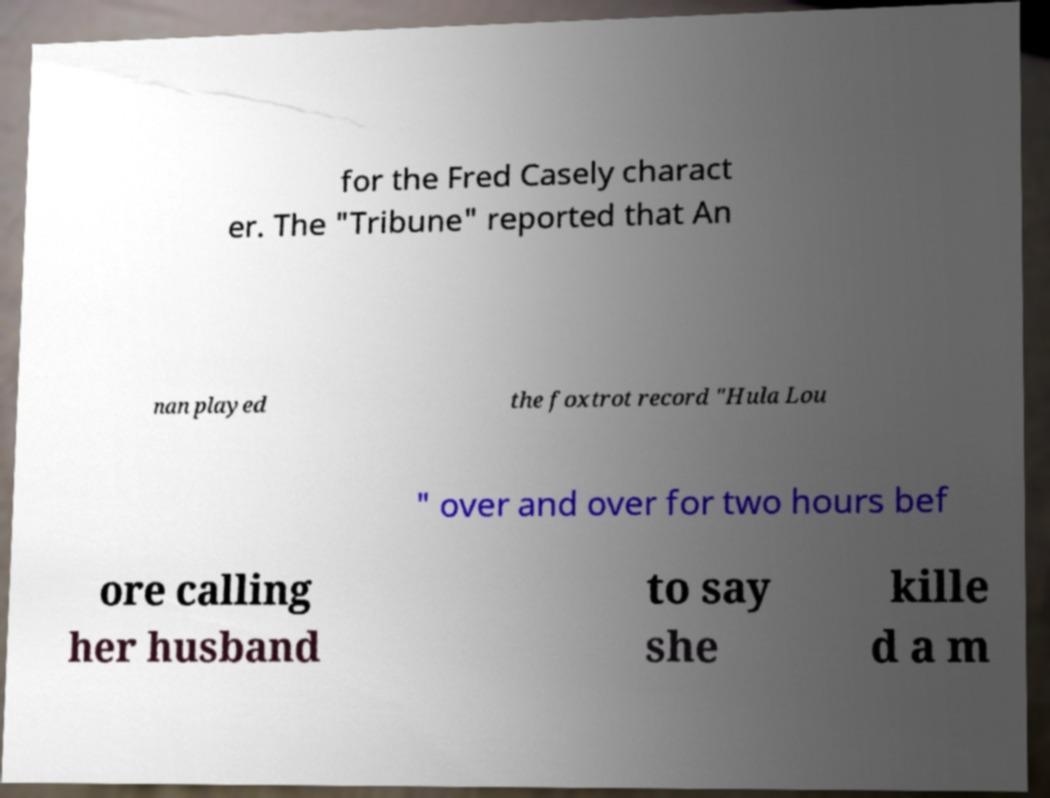Could you assist in decoding the text presented in this image and type it out clearly? for the Fred Casely charact er. The "Tribune" reported that An nan played the foxtrot record "Hula Lou " over and over for two hours bef ore calling her husband to say she kille d a m 